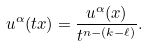<formula> <loc_0><loc_0><loc_500><loc_500>u ^ { \alpha } ( t x ) = \frac { u ^ { \alpha } ( x ) } { t ^ { n - ( k - \ell ) } } .</formula> 